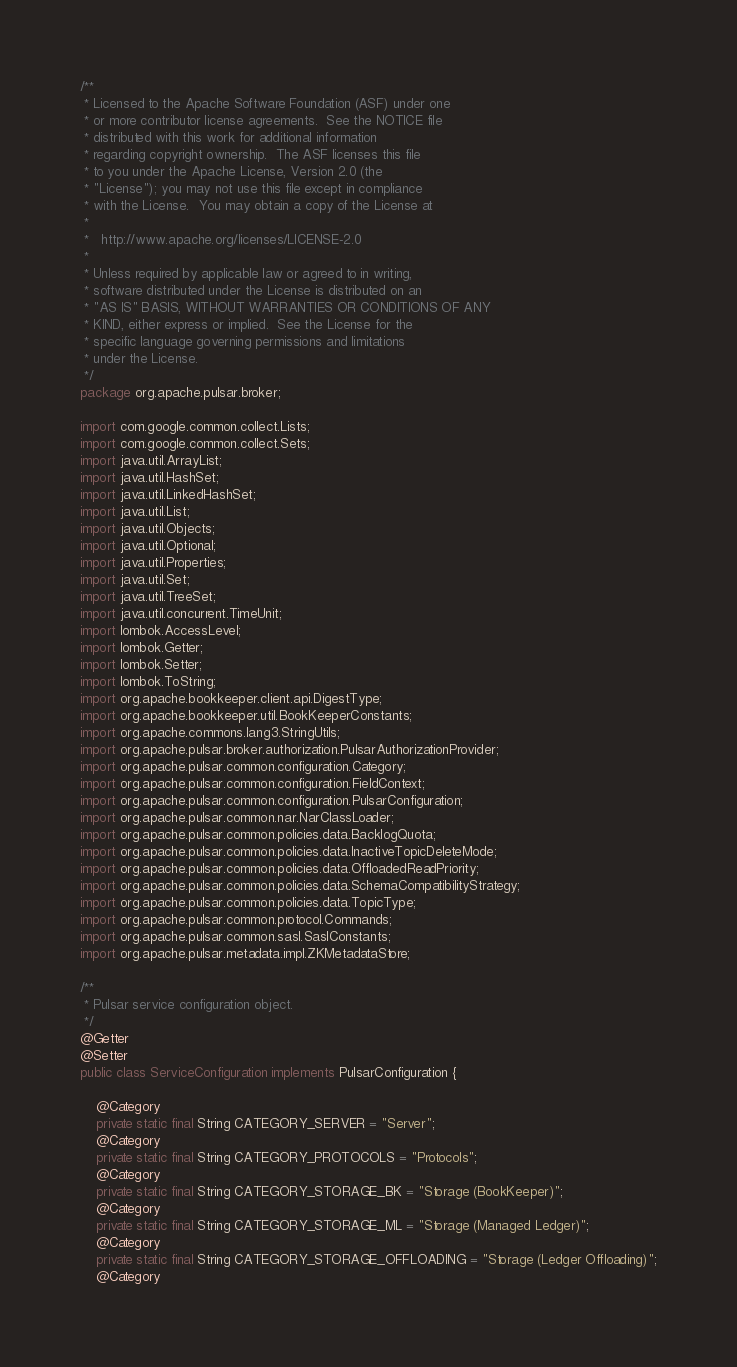<code> <loc_0><loc_0><loc_500><loc_500><_Java_>/**
 * Licensed to the Apache Software Foundation (ASF) under one
 * or more contributor license agreements.  See the NOTICE file
 * distributed with this work for additional information
 * regarding copyright ownership.  The ASF licenses this file
 * to you under the Apache License, Version 2.0 (the
 * "License"); you may not use this file except in compliance
 * with the License.  You may obtain a copy of the License at
 *
 *   http://www.apache.org/licenses/LICENSE-2.0
 *
 * Unless required by applicable law or agreed to in writing,
 * software distributed under the License is distributed on an
 * "AS IS" BASIS, WITHOUT WARRANTIES OR CONDITIONS OF ANY
 * KIND, either express or implied.  See the License for the
 * specific language governing permissions and limitations
 * under the License.
 */
package org.apache.pulsar.broker;

import com.google.common.collect.Lists;
import com.google.common.collect.Sets;
import java.util.ArrayList;
import java.util.HashSet;
import java.util.LinkedHashSet;
import java.util.List;
import java.util.Objects;
import java.util.Optional;
import java.util.Properties;
import java.util.Set;
import java.util.TreeSet;
import java.util.concurrent.TimeUnit;
import lombok.AccessLevel;
import lombok.Getter;
import lombok.Setter;
import lombok.ToString;
import org.apache.bookkeeper.client.api.DigestType;
import org.apache.bookkeeper.util.BookKeeperConstants;
import org.apache.commons.lang3.StringUtils;
import org.apache.pulsar.broker.authorization.PulsarAuthorizationProvider;
import org.apache.pulsar.common.configuration.Category;
import org.apache.pulsar.common.configuration.FieldContext;
import org.apache.pulsar.common.configuration.PulsarConfiguration;
import org.apache.pulsar.common.nar.NarClassLoader;
import org.apache.pulsar.common.policies.data.BacklogQuota;
import org.apache.pulsar.common.policies.data.InactiveTopicDeleteMode;
import org.apache.pulsar.common.policies.data.OffloadedReadPriority;
import org.apache.pulsar.common.policies.data.SchemaCompatibilityStrategy;
import org.apache.pulsar.common.policies.data.TopicType;
import org.apache.pulsar.common.protocol.Commands;
import org.apache.pulsar.common.sasl.SaslConstants;
import org.apache.pulsar.metadata.impl.ZKMetadataStore;

/**
 * Pulsar service configuration object.
 */
@Getter
@Setter
public class ServiceConfiguration implements PulsarConfiguration {

    @Category
    private static final String CATEGORY_SERVER = "Server";
    @Category
    private static final String CATEGORY_PROTOCOLS = "Protocols";
    @Category
    private static final String CATEGORY_STORAGE_BK = "Storage (BookKeeper)";
    @Category
    private static final String CATEGORY_STORAGE_ML = "Storage (Managed Ledger)";
    @Category
    private static final String CATEGORY_STORAGE_OFFLOADING = "Storage (Ledger Offloading)";
    @Category</code> 